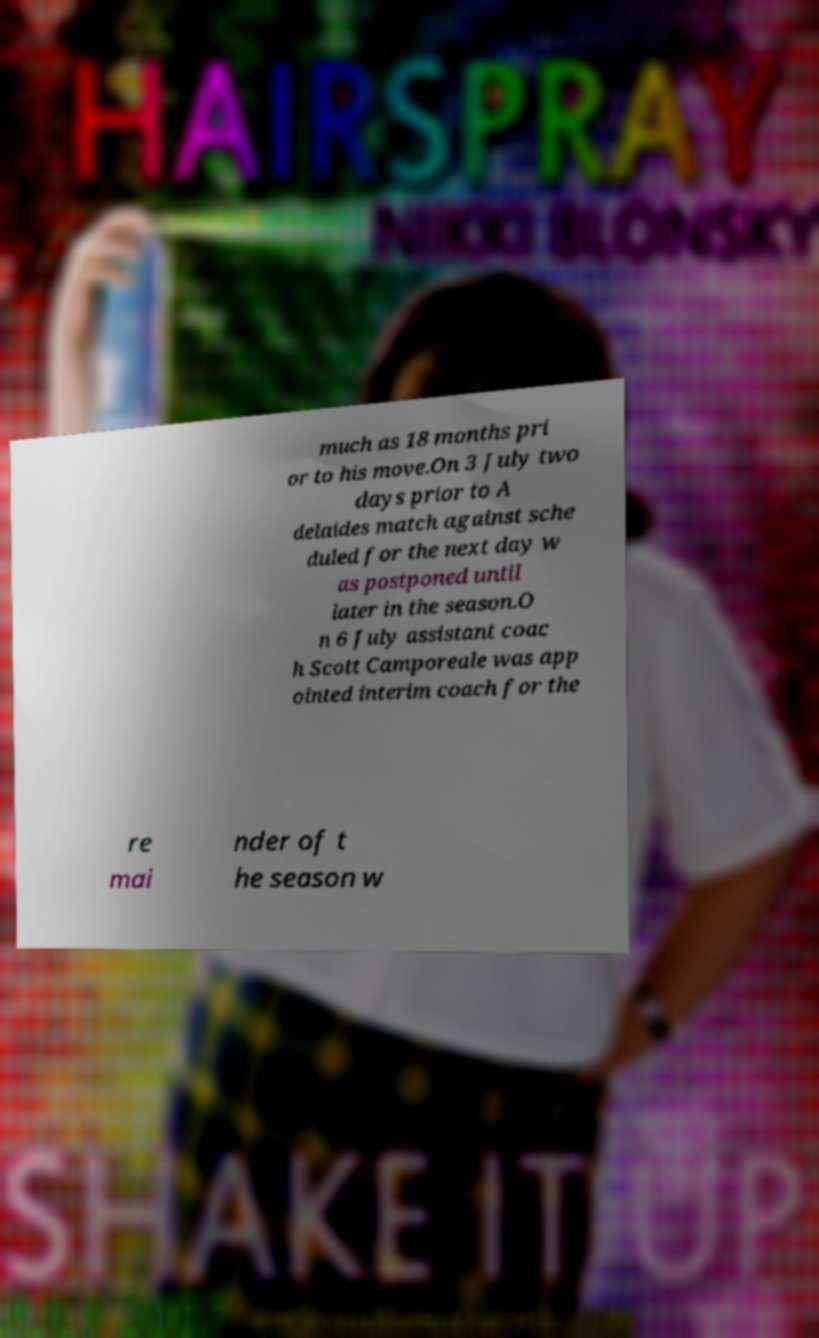What messages or text are displayed in this image? I need them in a readable, typed format. much as 18 months pri or to his move.On 3 July two days prior to A delaides match against sche duled for the next day w as postponed until later in the season.O n 6 July assistant coac h Scott Camporeale was app ointed interim coach for the re mai nder of t he season w 